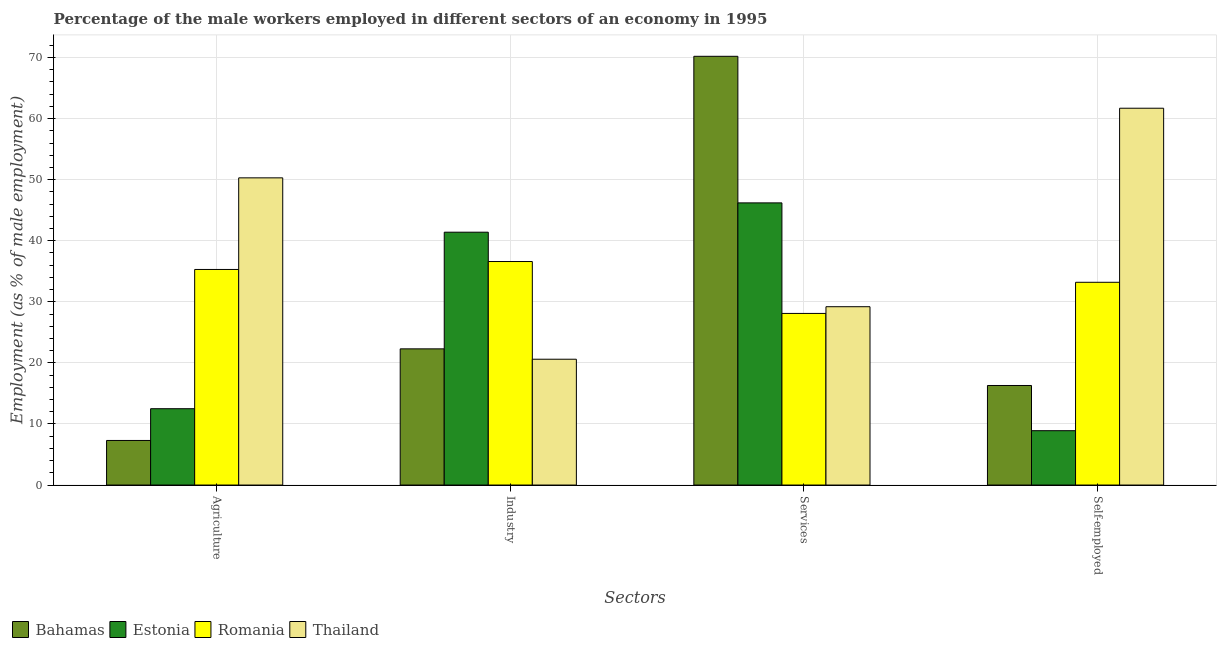How many different coloured bars are there?
Provide a succinct answer. 4. How many groups of bars are there?
Offer a very short reply. 4. Are the number of bars per tick equal to the number of legend labels?
Your answer should be compact. Yes. What is the label of the 1st group of bars from the left?
Give a very brief answer. Agriculture. What is the percentage of male workers in industry in Estonia?
Keep it short and to the point. 41.4. Across all countries, what is the maximum percentage of male workers in industry?
Your response must be concise. 41.4. Across all countries, what is the minimum percentage of male workers in services?
Your response must be concise. 28.1. In which country was the percentage of male workers in services maximum?
Provide a short and direct response. Bahamas. In which country was the percentage of male workers in industry minimum?
Your answer should be compact. Thailand. What is the total percentage of self employed male workers in the graph?
Give a very brief answer. 120.1. What is the difference between the percentage of male workers in services in Thailand and that in Romania?
Your answer should be very brief. 1.1. What is the difference between the percentage of male workers in industry in Thailand and the percentage of male workers in services in Bahamas?
Your answer should be compact. -49.6. What is the average percentage of male workers in industry per country?
Provide a short and direct response. 30.22. What is the difference between the percentage of male workers in agriculture and percentage of male workers in services in Thailand?
Ensure brevity in your answer.  21.1. What is the ratio of the percentage of male workers in industry in Thailand to that in Estonia?
Offer a terse response. 0.5. Is the percentage of self employed male workers in Romania less than that in Bahamas?
Your answer should be compact. No. What is the difference between the highest and the second highest percentage of male workers in services?
Offer a very short reply. 24. What is the difference between the highest and the lowest percentage of male workers in agriculture?
Your answer should be compact. 43. In how many countries, is the percentage of male workers in agriculture greater than the average percentage of male workers in agriculture taken over all countries?
Your response must be concise. 2. Is it the case that in every country, the sum of the percentage of male workers in services and percentage of male workers in agriculture is greater than the sum of percentage of male workers in industry and percentage of self employed male workers?
Your answer should be compact. No. What does the 2nd bar from the left in Industry represents?
Keep it short and to the point. Estonia. What does the 2nd bar from the right in Agriculture represents?
Your response must be concise. Romania. Are all the bars in the graph horizontal?
Your answer should be very brief. No. What is the difference between two consecutive major ticks on the Y-axis?
Offer a very short reply. 10. Does the graph contain any zero values?
Make the answer very short. No. Where does the legend appear in the graph?
Make the answer very short. Bottom left. How many legend labels are there?
Your response must be concise. 4. How are the legend labels stacked?
Your answer should be compact. Horizontal. What is the title of the graph?
Your answer should be compact. Percentage of the male workers employed in different sectors of an economy in 1995. Does "Togo" appear as one of the legend labels in the graph?
Provide a short and direct response. No. What is the label or title of the X-axis?
Your response must be concise. Sectors. What is the label or title of the Y-axis?
Your response must be concise. Employment (as % of male employment). What is the Employment (as % of male employment) in Bahamas in Agriculture?
Your answer should be very brief. 7.3. What is the Employment (as % of male employment) of Estonia in Agriculture?
Give a very brief answer. 12.5. What is the Employment (as % of male employment) of Romania in Agriculture?
Give a very brief answer. 35.3. What is the Employment (as % of male employment) in Thailand in Agriculture?
Your answer should be compact. 50.3. What is the Employment (as % of male employment) in Bahamas in Industry?
Your response must be concise. 22.3. What is the Employment (as % of male employment) of Estonia in Industry?
Your answer should be compact. 41.4. What is the Employment (as % of male employment) of Romania in Industry?
Make the answer very short. 36.6. What is the Employment (as % of male employment) of Thailand in Industry?
Your answer should be compact. 20.6. What is the Employment (as % of male employment) of Bahamas in Services?
Keep it short and to the point. 70.2. What is the Employment (as % of male employment) in Estonia in Services?
Offer a terse response. 46.2. What is the Employment (as % of male employment) in Romania in Services?
Offer a very short reply. 28.1. What is the Employment (as % of male employment) in Thailand in Services?
Your answer should be compact. 29.2. What is the Employment (as % of male employment) in Bahamas in Self-employed?
Provide a short and direct response. 16.3. What is the Employment (as % of male employment) of Estonia in Self-employed?
Your response must be concise. 8.9. What is the Employment (as % of male employment) of Romania in Self-employed?
Your answer should be compact. 33.2. What is the Employment (as % of male employment) in Thailand in Self-employed?
Offer a terse response. 61.7. Across all Sectors, what is the maximum Employment (as % of male employment) in Bahamas?
Make the answer very short. 70.2. Across all Sectors, what is the maximum Employment (as % of male employment) of Estonia?
Your answer should be very brief. 46.2. Across all Sectors, what is the maximum Employment (as % of male employment) of Romania?
Your answer should be compact. 36.6. Across all Sectors, what is the maximum Employment (as % of male employment) of Thailand?
Give a very brief answer. 61.7. Across all Sectors, what is the minimum Employment (as % of male employment) of Bahamas?
Give a very brief answer. 7.3. Across all Sectors, what is the minimum Employment (as % of male employment) of Estonia?
Provide a succinct answer. 8.9. Across all Sectors, what is the minimum Employment (as % of male employment) of Romania?
Your answer should be very brief. 28.1. Across all Sectors, what is the minimum Employment (as % of male employment) of Thailand?
Your response must be concise. 20.6. What is the total Employment (as % of male employment) of Bahamas in the graph?
Your answer should be very brief. 116.1. What is the total Employment (as % of male employment) of Estonia in the graph?
Your answer should be compact. 109. What is the total Employment (as % of male employment) of Romania in the graph?
Your answer should be compact. 133.2. What is the total Employment (as % of male employment) in Thailand in the graph?
Offer a very short reply. 161.8. What is the difference between the Employment (as % of male employment) of Estonia in Agriculture and that in Industry?
Provide a succinct answer. -28.9. What is the difference between the Employment (as % of male employment) of Romania in Agriculture and that in Industry?
Make the answer very short. -1.3. What is the difference between the Employment (as % of male employment) in Thailand in Agriculture and that in Industry?
Offer a terse response. 29.7. What is the difference between the Employment (as % of male employment) in Bahamas in Agriculture and that in Services?
Offer a very short reply. -62.9. What is the difference between the Employment (as % of male employment) of Estonia in Agriculture and that in Services?
Keep it short and to the point. -33.7. What is the difference between the Employment (as % of male employment) in Thailand in Agriculture and that in Services?
Your response must be concise. 21.1. What is the difference between the Employment (as % of male employment) of Estonia in Agriculture and that in Self-employed?
Give a very brief answer. 3.6. What is the difference between the Employment (as % of male employment) of Romania in Agriculture and that in Self-employed?
Make the answer very short. 2.1. What is the difference between the Employment (as % of male employment) in Thailand in Agriculture and that in Self-employed?
Your answer should be compact. -11.4. What is the difference between the Employment (as % of male employment) of Bahamas in Industry and that in Services?
Offer a very short reply. -47.9. What is the difference between the Employment (as % of male employment) of Romania in Industry and that in Services?
Your response must be concise. 8.5. What is the difference between the Employment (as % of male employment) of Bahamas in Industry and that in Self-employed?
Your answer should be compact. 6. What is the difference between the Employment (as % of male employment) in Estonia in Industry and that in Self-employed?
Ensure brevity in your answer.  32.5. What is the difference between the Employment (as % of male employment) in Romania in Industry and that in Self-employed?
Make the answer very short. 3.4. What is the difference between the Employment (as % of male employment) of Thailand in Industry and that in Self-employed?
Make the answer very short. -41.1. What is the difference between the Employment (as % of male employment) in Bahamas in Services and that in Self-employed?
Provide a short and direct response. 53.9. What is the difference between the Employment (as % of male employment) of Estonia in Services and that in Self-employed?
Your answer should be compact. 37.3. What is the difference between the Employment (as % of male employment) of Thailand in Services and that in Self-employed?
Your answer should be very brief. -32.5. What is the difference between the Employment (as % of male employment) in Bahamas in Agriculture and the Employment (as % of male employment) in Estonia in Industry?
Your response must be concise. -34.1. What is the difference between the Employment (as % of male employment) in Bahamas in Agriculture and the Employment (as % of male employment) in Romania in Industry?
Provide a succinct answer. -29.3. What is the difference between the Employment (as % of male employment) of Bahamas in Agriculture and the Employment (as % of male employment) of Thailand in Industry?
Ensure brevity in your answer.  -13.3. What is the difference between the Employment (as % of male employment) in Estonia in Agriculture and the Employment (as % of male employment) in Romania in Industry?
Make the answer very short. -24.1. What is the difference between the Employment (as % of male employment) of Estonia in Agriculture and the Employment (as % of male employment) of Thailand in Industry?
Your answer should be compact. -8.1. What is the difference between the Employment (as % of male employment) in Bahamas in Agriculture and the Employment (as % of male employment) in Estonia in Services?
Your answer should be very brief. -38.9. What is the difference between the Employment (as % of male employment) of Bahamas in Agriculture and the Employment (as % of male employment) of Romania in Services?
Offer a very short reply. -20.8. What is the difference between the Employment (as % of male employment) of Bahamas in Agriculture and the Employment (as % of male employment) of Thailand in Services?
Your answer should be very brief. -21.9. What is the difference between the Employment (as % of male employment) of Estonia in Agriculture and the Employment (as % of male employment) of Romania in Services?
Your response must be concise. -15.6. What is the difference between the Employment (as % of male employment) in Estonia in Agriculture and the Employment (as % of male employment) in Thailand in Services?
Your answer should be very brief. -16.7. What is the difference between the Employment (as % of male employment) in Bahamas in Agriculture and the Employment (as % of male employment) in Romania in Self-employed?
Give a very brief answer. -25.9. What is the difference between the Employment (as % of male employment) of Bahamas in Agriculture and the Employment (as % of male employment) of Thailand in Self-employed?
Offer a very short reply. -54.4. What is the difference between the Employment (as % of male employment) in Estonia in Agriculture and the Employment (as % of male employment) in Romania in Self-employed?
Ensure brevity in your answer.  -20.7. What is the difference between the Employment (as % of male employment) of Estonia in Agriculture and the Employment (as % of male employment) of Thailand in Self-employed?
Your response must be concise. -49.2. What is the difference between the Employment (as % of male employment) of Romania in Agriculture and the Employment (as % of male employment) of Thailand in Self-employed?
Make the answer very short. -26.4. What is the difference between the Employment (as % of male employment) of Bahamas in Industry and the Employment (as % of male employment) of Estonia in Services?
Give a very brief answer. -23.9. What is the difference between the Employment (as % of male employment) in Bahamas in Industry and the Employment (as % of male employment) in Thailand in Services?
Your response must be concise. -6.9. What is the difference between the Employment (as % of male employment) in Estonia in Industry and the Employment (as % of male employment) in Romania in Services?
Give a very brief answer. 13.3. What is the difference between the Employment (as % of male employment) in Romania in Industry and the Employment (as % of male employment) in Thailand in Services?
Your answer should be very brief. 7.4. What is the difference between the Employment (as % of male employment) of Bahamas in Industry and the Employment (as % of male employment) of Estonia in Self-employed?
Offer a very short reply. 13.4. What is the difference between the Employment (as % of male employment) in Bahamas in Industry and the Employment (as % of male employment) in Romania in Self-employed?
Offer a very short reply. -10.9. What is the difference between the Employment (as % of male employment) of Bahamas in Industry and the Employment (as % of male employment) of Thailand in Self-employed?
Your answer should be very brief. -39.4. What is the difference between the Employment (as % of male employment) of Estonia in Industry and the Employment (as % of male employment) of Romania in Self-employed?
Ensure brevity in your answer.  8.2. What is the difference between the Employment (as % of male employment) in Estonia in Industry and the Employment (as % of male employment) in Thailand in Self-employed?
Provide a succinct answer. -20.3. What is the difference between the Employment (as % of male employment) of Romania in Industry and the Employment (as % of male employment) of Thailand in Self-employed?
Your response must be concise. -25.1. What is the difference between the Employment (as % of male employment) in Bahamas in Services and the Employment (as % of male employment) in Estonia in Self-employed?
Make the answer very short. 61.3. What is the difference between the Employment (as % of male employment) of Bahamas in Services and the Employment (as % of male employment) of Romania in Self-employed?
Ensure brevity in your answer.  37. What is the difference between the Employment (as % of male employment) in Estonia in Services and the Employment (as % of male employment) in Romania in Self-employed?
Make the answer very short. 13. What is the difference between the Employment (as % of male employment) of Estonia in Services and the Employment (as % of male employment) of Thailand in Self-employed?
Give a very brief answer. -15.5. What is the difference between the Employment (as % of male employment) of Romania in Services and the Employment (as % of male employment) of Thailand in Self-employed?
Provide a short and direct response. -33.6. What is the average Employment (as % of male employment) in Bahamas per Sectors?
Provide a succinct answer. 29.02. What is the average Employment (as % of male employment) of Estonia per Sectors?
Your response must be concise. 27.25. What is the average Employment (as % of male employment) of Romania per Sectors?
Offer a terse response. 33.3. What is the average Employment (as % of male employment) in Thailand per Sectors?
Make the answer very short. 40.45. What is the difference between the Employment (as % of male employment) of Bahamas and Employment (as % of male employment) of Romania in Agriculture?
Give a very brief answer. -28. What is the difference between the Employment (as % of male employment) in Bahamas and Employment (as % of male employment) in Thailand in Agriculture?
Offer a terse response. -43. What is the difference between the Employment (as % of male employment) of Estonia and Employment (as % of male employment) of Romania in Agriculture?
Your answer should be very brief. -22.8. What is the difference between the Employment (as % of male employment) in Estonia and Employment (as % of male employment) in Thailand in Agriculture?
Offer a terse response. -37.8. What is the difference between the Employment (as % of male employment) in Romania and Employment (as % of male employment) in Thailand in Agriculture?
Your response must be concise. -15. What is the difference between the Employment (as % of male employment) of Bahamas and Employment (as % of male employment) of Estonia in Industry?
Ensure brevity in your answer.  -19.1. What is the difference between the Employment (as % of male employment) in Bahamas and Employment (as % of male employment) in Romania in Industry?
Keep it short and to the point. -14.3. What is the difference between the Employment (as % of male employment) of Estonia and Employment (as % of male employment) of Thailand in Industry?
Provide a short and direct response. 20.8. What is the difference between the Employment (as % of male employment) in Bahamas and Employment (as % of male employment) in Romania in Services?
Give a very brief answer. 42.1. What is the difference between the Employment (as % of male employment) of Bahamas and Employment (as % of male employment) of Thailand in Services?
Keep it short and to the point. 41. What is the difference between the Employment (as % of male employment) of Romania and Employment (as % of male employment) of Thailand in Services?
Offer a very short reply. -1.1. What is the difference between the Employment (as % of male employment) of Bahamas and Employment (as % of male employment) of Romania in Self-employed?
Your answer should be very brief. -16.9. What is the difference between the Employment (as % of male employment) of Bahamas and Employment (as % of male employment) of Thailand in Self-employed?
Keep it short and to the point. -45.4. What is the difference between the Employment (as % of male employment) in Estonia and Employment (as % of male employment) in Romania in Self-employed?
Keep it short and to the point. -24.3. What is the difference between the Employment (as % of male employment) of Estonia and Employment (as % of male employment) of Thailand in Self-employed?
Offer a terse response. -52.8. What is the difference between the Employment (as % of male employment) of Romania and Employment (as % of male employment) of Thailand in Self-employed?
Your response must be concise. -28.5. What is the ratio of the Employment (as % of male employment) in Bahamas in Agriculture to that in Industry?
Your answer should be very brief. 0.33. What is the ratio of the Employment (as % of male employment) in Estonia in Agriculture to that in Industry?
Your answer should be compact. 0.3. What is the ratio of the Employment (as % of male employment) in Romania in Agriculture to that in Industry?
Give a very brief answer. 0.96. What is the ratio of the Employment (as % of male employment) of Thailand in Agriculture to that in Industry?
Keep it short and to the point. 2.44. What is the ratio of the Employment (as % of male employment) in Bahamas in Agriculture to that in Services?
Provide a succinct answer. 0.1. What is the ratio of the Employment (as % of male employment) in Estonia in Agriculture to that in Services?
Your response must be concise. 0.27. What is the ratio of the Employment (as % of male employment) in Romania in Agriculture to that in Services?
Your answer should be compact. 1.26. What is the ratio of the Employment (as % of male employment) in Thailand in Agriculture to that in Services?
Ensure brevity in your answer.  1.72. What is the ratio of the Employment (as % of male employment) in Bahamas in Agriculture to that in Self-employed?
Your answer should be very brief. 0.45. What is the ratio of the Employment (as % of male employment) of Estonia in Agriculture to that in Self-employed?
Make the answer very short. 1.4. What is the ratio of the Employment (as % of male employment) of Romania in Agriculture to that in Self-employed?
Ensure brevity in your answer.  1.06. What is the ratio of the Employment (as % of male employment) of Thailand in Agriculture to that in Self-employed?
Make the answer very short. 0.82. What is the ratio of the Employment (as % of male employment) in Bahamas in Industry to that in Services?
Offer a terse response. 0.32. What is the ratio of the Employment (as % of male employment) in Estonia in Industry to that in Services?
Provide a succinct answer. 0.9. What is the ratio of the Employment (as % of male employment) in Romania in Industry to that in Services?
Provide a short and direct response. 1.3. What is the ratio of the Employment (as % of male employment) in Thailand in Industry to that in Services?
Ensure brevity in your answer.  0.71. What is the ratio of the Employment (as % of male employment) in Bahamas in Industry to that in Self-employed?
Keep it short and to the point. 1.37. What is the ratio of the Employment (as % of male employment) of Estonia in Industry to that in Self-employed?
Give a very brief answer. 4.65. What is the ratio of the Employment (as % of male employment) of Romania in Industry to that in Self-employed?
Your answer should be very brief. 1.1. What is the ratio of the Employment (as % of male employment) in Thailand in Industry to that in Self-employed?
Provide a succinct answer. 0.33. What is the ratio of the Employment (as % of male employment) of Bahamas in Services to that in Self-employed?
Make the answer very short. 4.31. What is the ratio of the Employment (as % of male employment) of Estonia in Services to that in Self-employed?
Provide a short and direct response. 5.19. What is the ratio of the Employment (as % of male employment) in Romania in Services to that in Self-employed?
Give a very brief answer. 0.85. What is the ratio of the Employment (as % of male employment) of Thailand in Services to that in Self-employed?
Ensure brevity in your answer.  0.47. What is the difference between the highest and the second highest Employment (as % of male employment) of Bahamas?
Provide a succinct answer. 47.9. What is the difference between the highest and the lowest Employment (as % of male employment) in Bahamas?
Your answer should be compact. 62.9. What is the difference between the highest and the lowest Employment (as % of male employment) in Estonia?
Offer a terse response. 37.3. What is the difference between the highest and the lowest Employment (as % of male employment) in Thailand?
Provide a short and direct response. 41.1. 